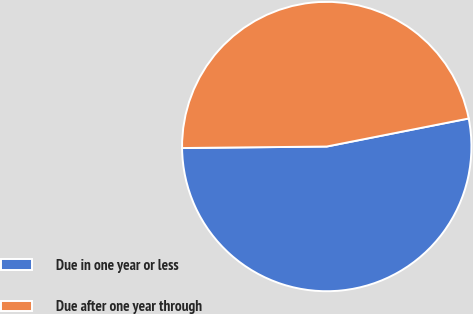Convert chart. <chart><loc_0><loc_0><loc_500><loc_500><pie_chart><fcel>Due in one year or less<fcel>Due after one year through<nl><fcel>52.94%<fcel>47.06%<nl></chart> 